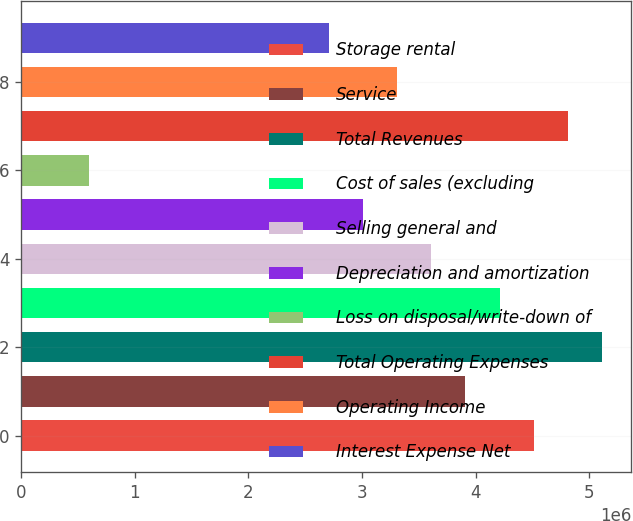Convert chart. <chart><loc_0><loc_0><loc_500><loc_500><bar_chart><fcel>Storage rental<fcel>Service<fcel>Total Revenues<fcel>Cost of sales (excluding<fcel>Selling general and<fcel>Depreciation and amortization<fcel>Loss on disposal/write-down of<fcel>Total Operating Expenses<fcel>Operating Income<fcel>Interest Expense Net<nl><fcel>4.51154e+06<fcel>3.91011e+06<fcel>5.11296e+06<fcel>4.21083e+06<fcel>3.6094e+06<fcel>3.00798e+06<fcel>602275<fcel>4.81225e+06<fcel>3.30869e+06<fcel>2.70726e+06<nl></chart> 